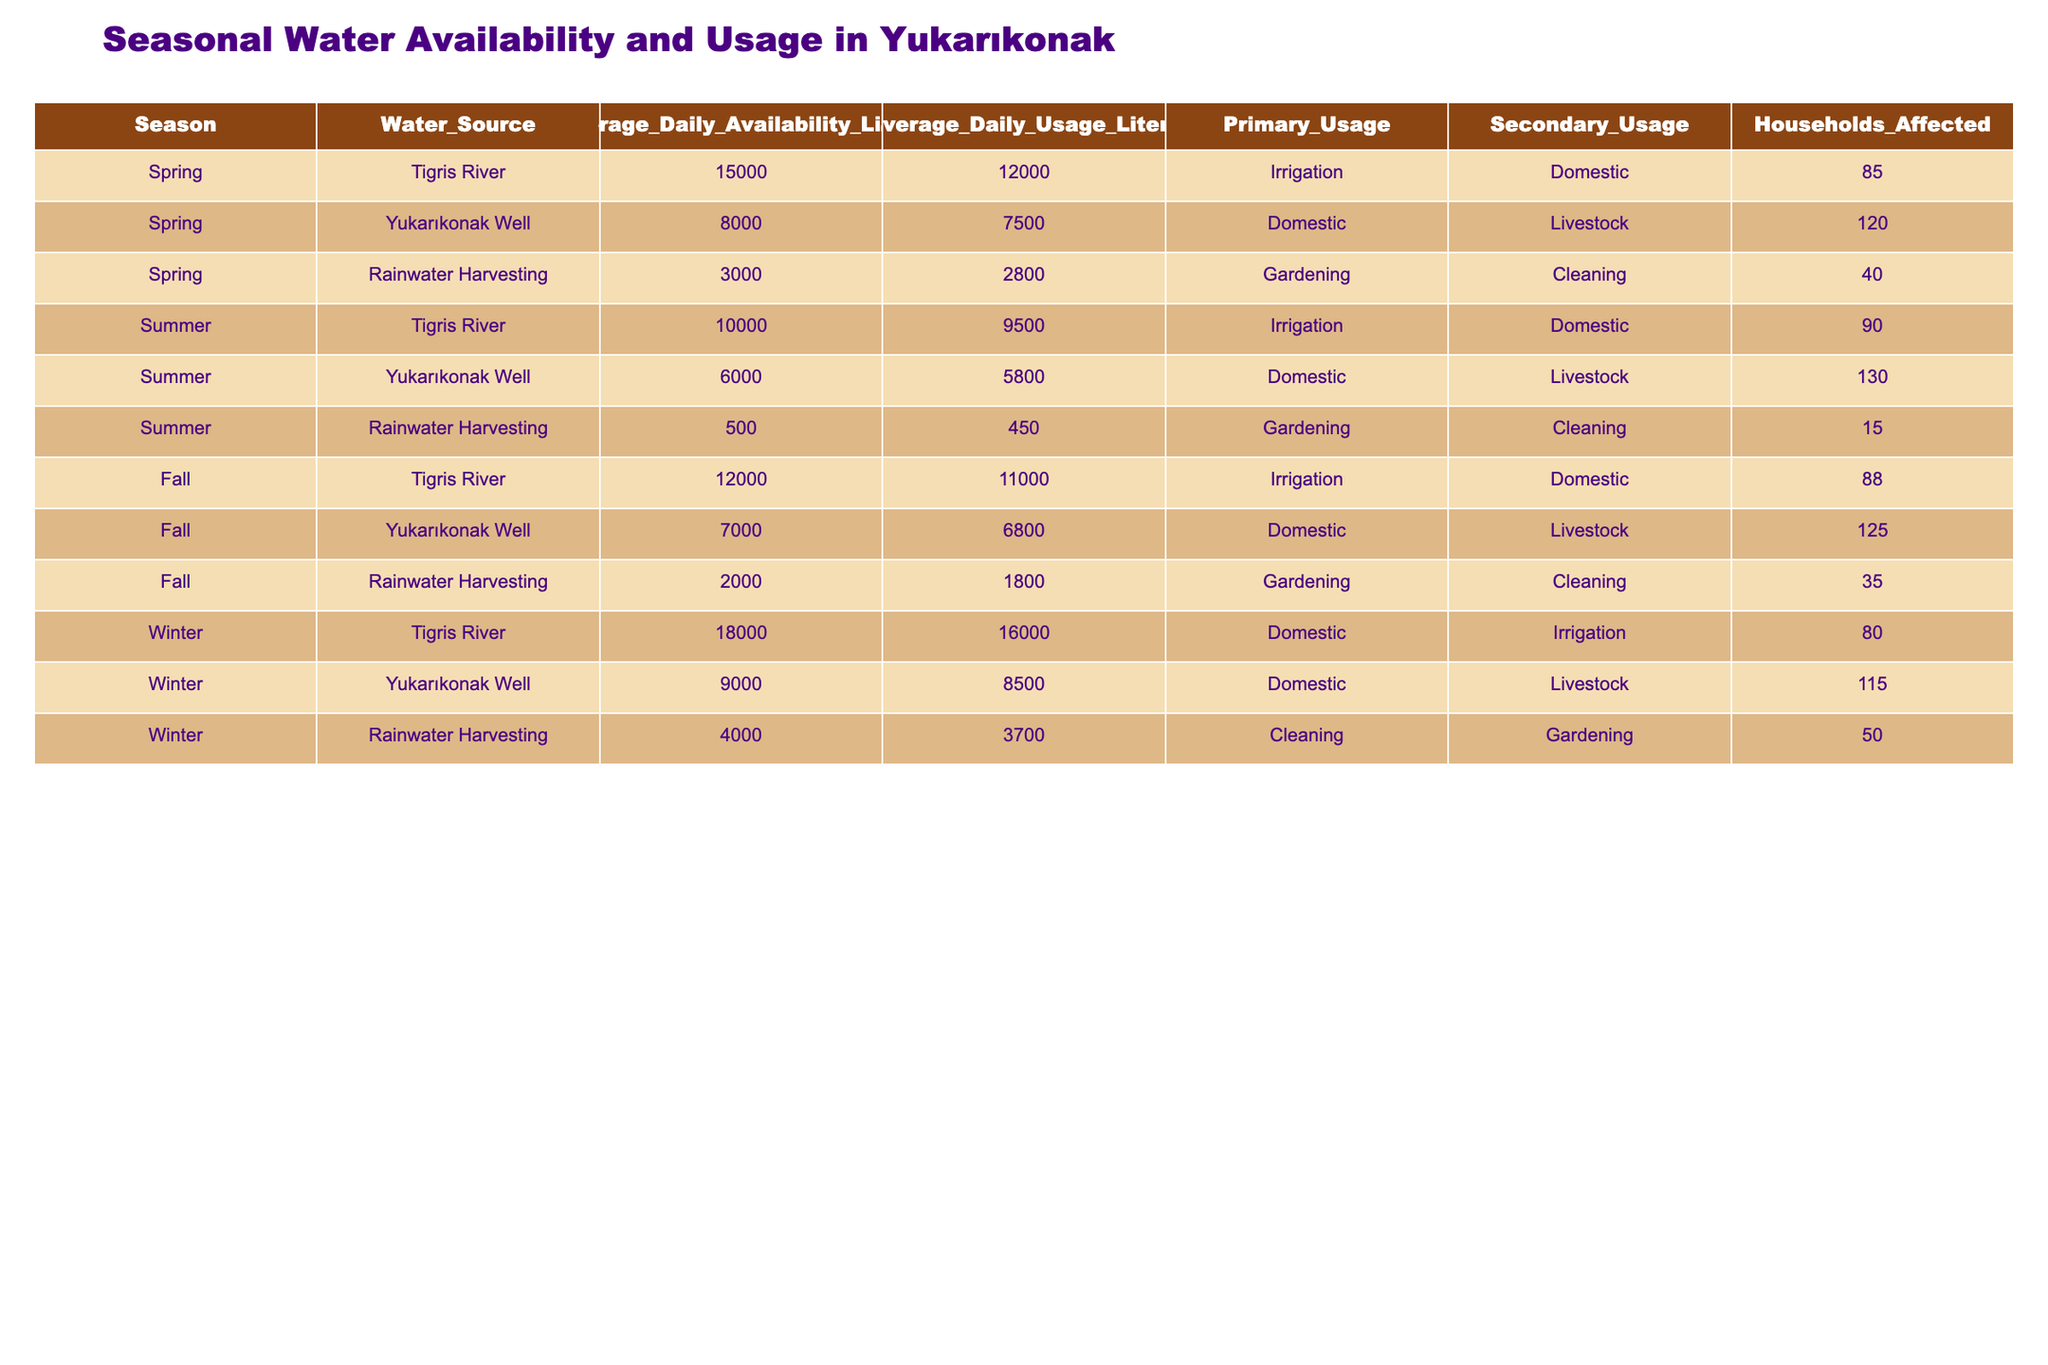What is the average daily water availability during Summer? From the table, we look for the Summer season and find the Average Daily Availability for each water source: Tigris River (10,000), Yukarıkonak Well (6,000), and Rainwater Harvesting (500). We sum these values (10,000 + 6,000 + 500 = 16,500) and divide by the number of sources (3) to calculate the average: 16,500 / 3 = 5,500
Answer: 5,500 Which water source has the highest average daily usage in Fall? In Fall, we examine the Average Daily Usage for each water source: Tigris River (11,000), Yukarıkonak Well (6,800), and Rainwater Harvesting (1,800). The highest value among these is 11,000 for the Tigris River.
Answer: Tigris River Are more households affected by the Yukarıkonak Well in Spring compared to Winter? We look at the Households Affected for the Yukarıkonak Well in Spring (120) and Winter (115). Comparing these values shows that 120 > 115, indicating more households are affected in Spring.
Answer: Yes What is the total average daily availability of water in the village during Spring? We sum the Average Daily Availability of water sources in Spring: Tigris River (15,000), Yukarıkonak Well (8,000), and Rainwater Harvesting (3,000). The total is 15,000 + 8,000 + 3,000 = 26,000.
Answer: 26,000 Is the average daily availability of the Tigris River in Winter higher than in Summer? We compare the Average Daily Availability for the Tigris River: Winter (18,000) and Summer (10,000). Since 18,000 > 10,000, the availability in Winter is indeed higher.
Answer: Yes What is the difference in average daily usage between the Tigris River in Winter and Fall? We extract the Average Daily Usage values: Winter (16,000) and Fall (11,000). The difference is 16,000 - 11,000 = 5,000 liters.
Answer: 5,000 Which season has the highest number of households affected by the Rainwater Harvesting? Looking at the Households Affected by Rainwater Harvesting: Spring (40), Summer (15), Fall (35), and Winter (50). The highest number is 50 in Winter.
Answer: Winter Calculate the average daily usage of water across all seasons for Yukarıkonak Well. We find the Average Daily Usage for Yukarıkonak Well in each season: Spring (7,500), Summer (5,800), Fall (6,800), and Winter (8,500). The total usage is 7,500 + 5,800 + 6,800 + 8,500 = 28,600, and dividing by 4 gives an average of 28,600 / 4 = 7,150.
Answer: 7,150 How does the average daily availability from Rainwater Harvesting compare across all seasons? We look at the Average Daily Availability of Rainwater Harvesting for all seasons: Spring (3,000), Summer (500), Fall (2,000), and Winter (4,000). The highest is in Winter (4,000) while the lowest is in Summer (500).
Answer: Highest in Winter, lowest in Summer Which water source is primarily used for irrigation in Fall? From the data, we check the Primary Usage for each water source in Fall: Tigris River is for Irrigation, Yukarıkonak Well is Domestic, and Rainwater Harvesting is Gardening. The Tigris River is the only one used primarily for irrigation.
Answer: Tigris River 